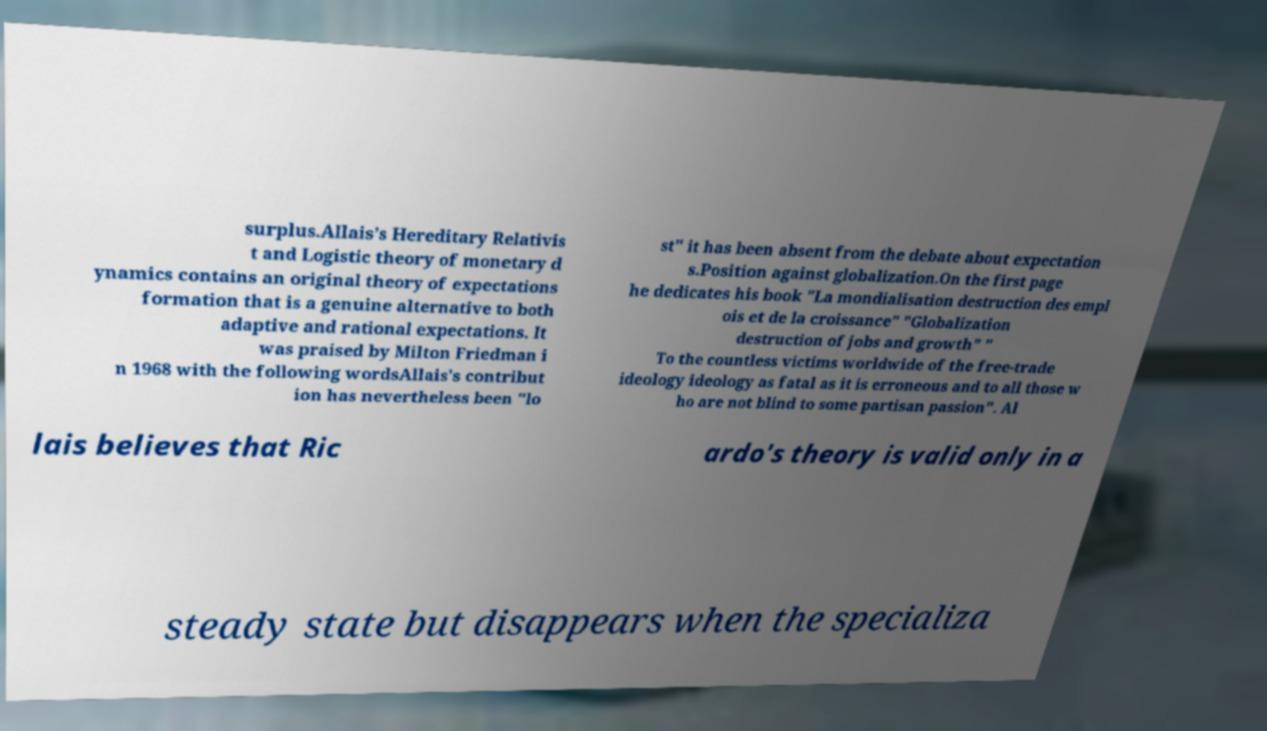Please identify and transcribe the text found in this image. surplus.Allais’s Hereditary Relativis t and Logistic theory of monetary d ynamics contains an original theory of expectations formation that is a genuine alternative to both adaptive and rational expectations. It was praised by Milton Friedman i n 1968 with the following wordsAllais's contribut ion has nevertheless been "lo st" it has been absent from the debate about expectation s.Position against globalization.On the first page he dedicates his book "La mondialisation destruction des empl ois et de la croissance" "Globalization destruction of jobs and growth" " To the countless victims worldwide of the free-trade ideology ideology as fatal as it is erroneous and to all those w ho are not blind to some partisan passion". Al lais believes that Ric ardo's theory is valid only in a steady state but disappears when the specializa 